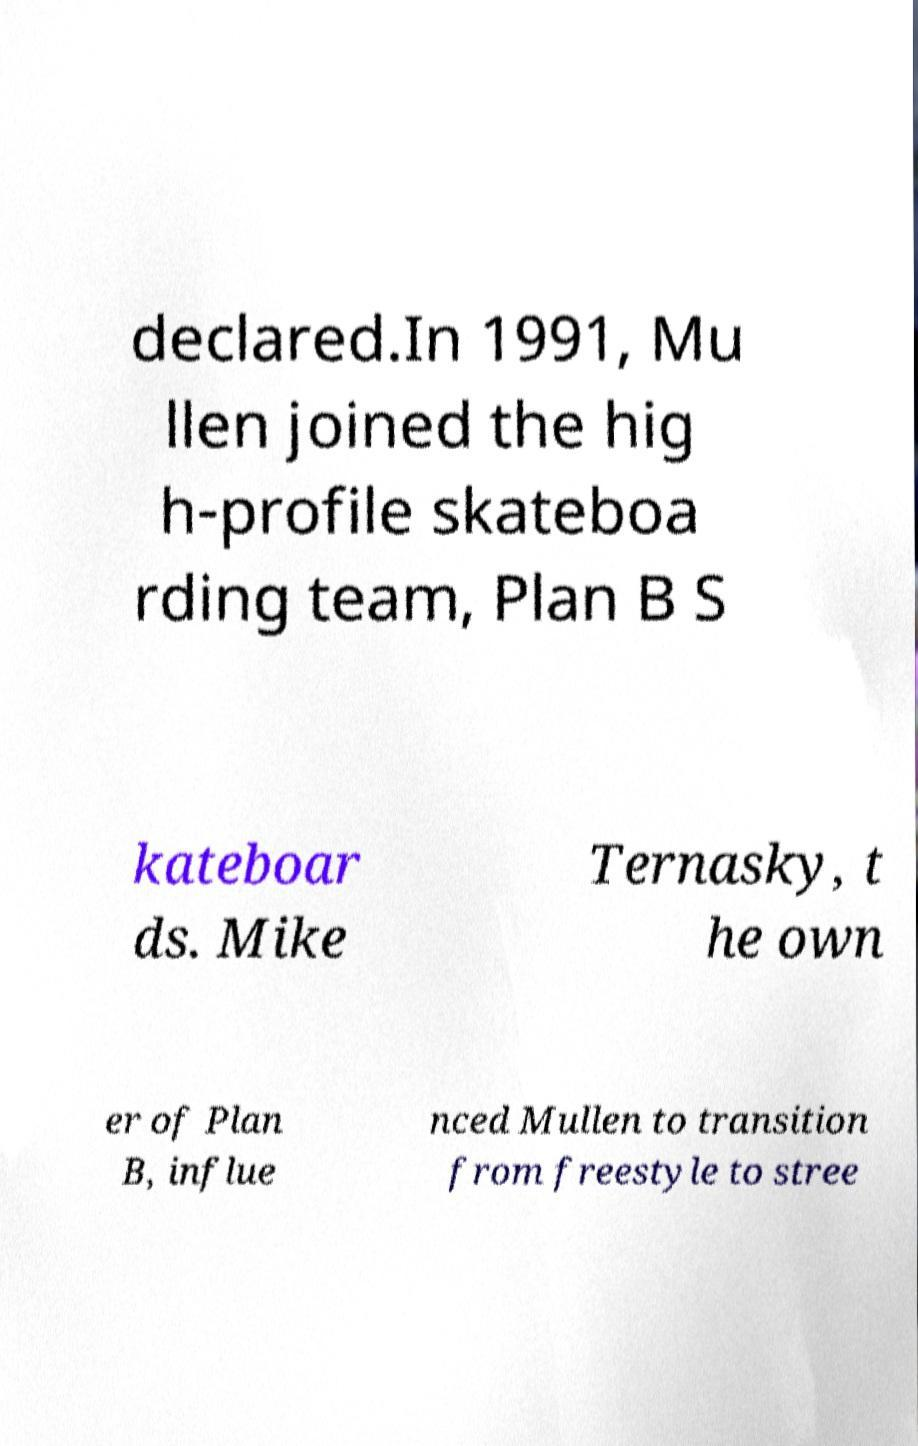Could you assist in decoding the text presented in this image and type it out clearly? declared.In 1991, Mu llen joined the hig h-profile skateboa rding team, Plan B S kateboar ds. Mike Ternasky, t he own er of Plan B, influe nced Mullen to transition from freestyle to stree 